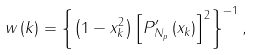Convert formula to latex. <formula><loc_0><loc_0><loc_500><loc_500>w \left ( k \right ) = \left \{ \left ( 1 - x _ { k } ^ { 2 } \right ) \left [ P _ { N _ { p } } ^ { \prime } \left ( x _ { k } \right ) \right ] ^ { 2 } \right \} ^ { - 1 } ,</formula> 